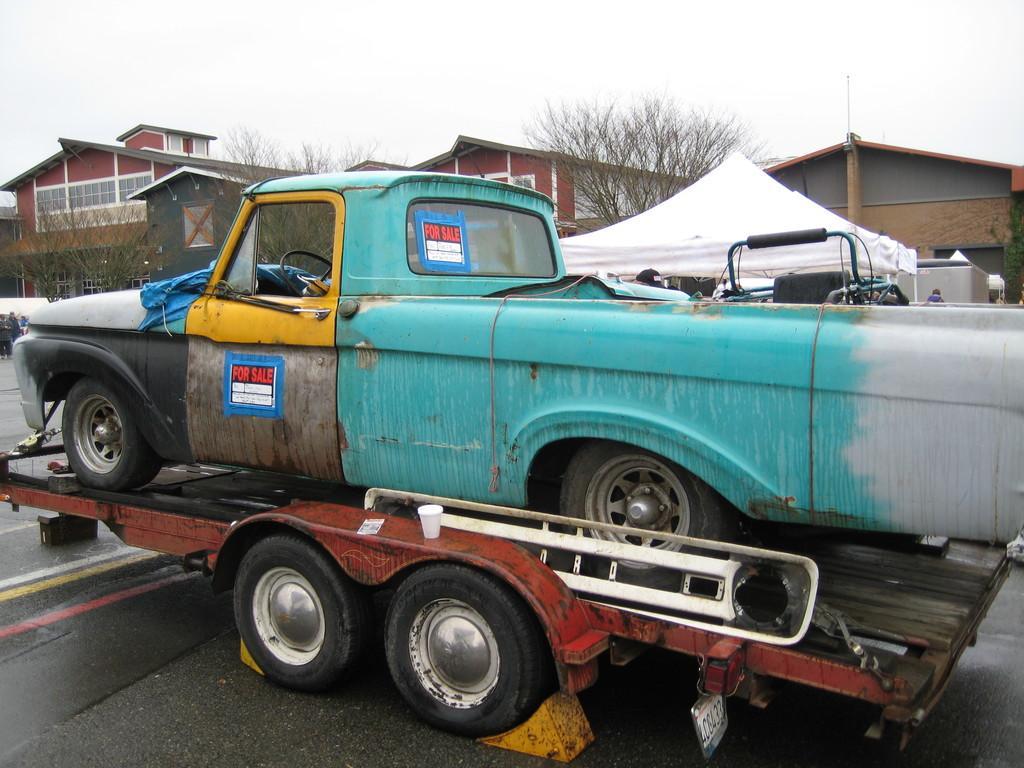Can you describe this image briefly? In the center of the image there is a car on the truck. In the background we can see trees, tent, buildings and sky. 